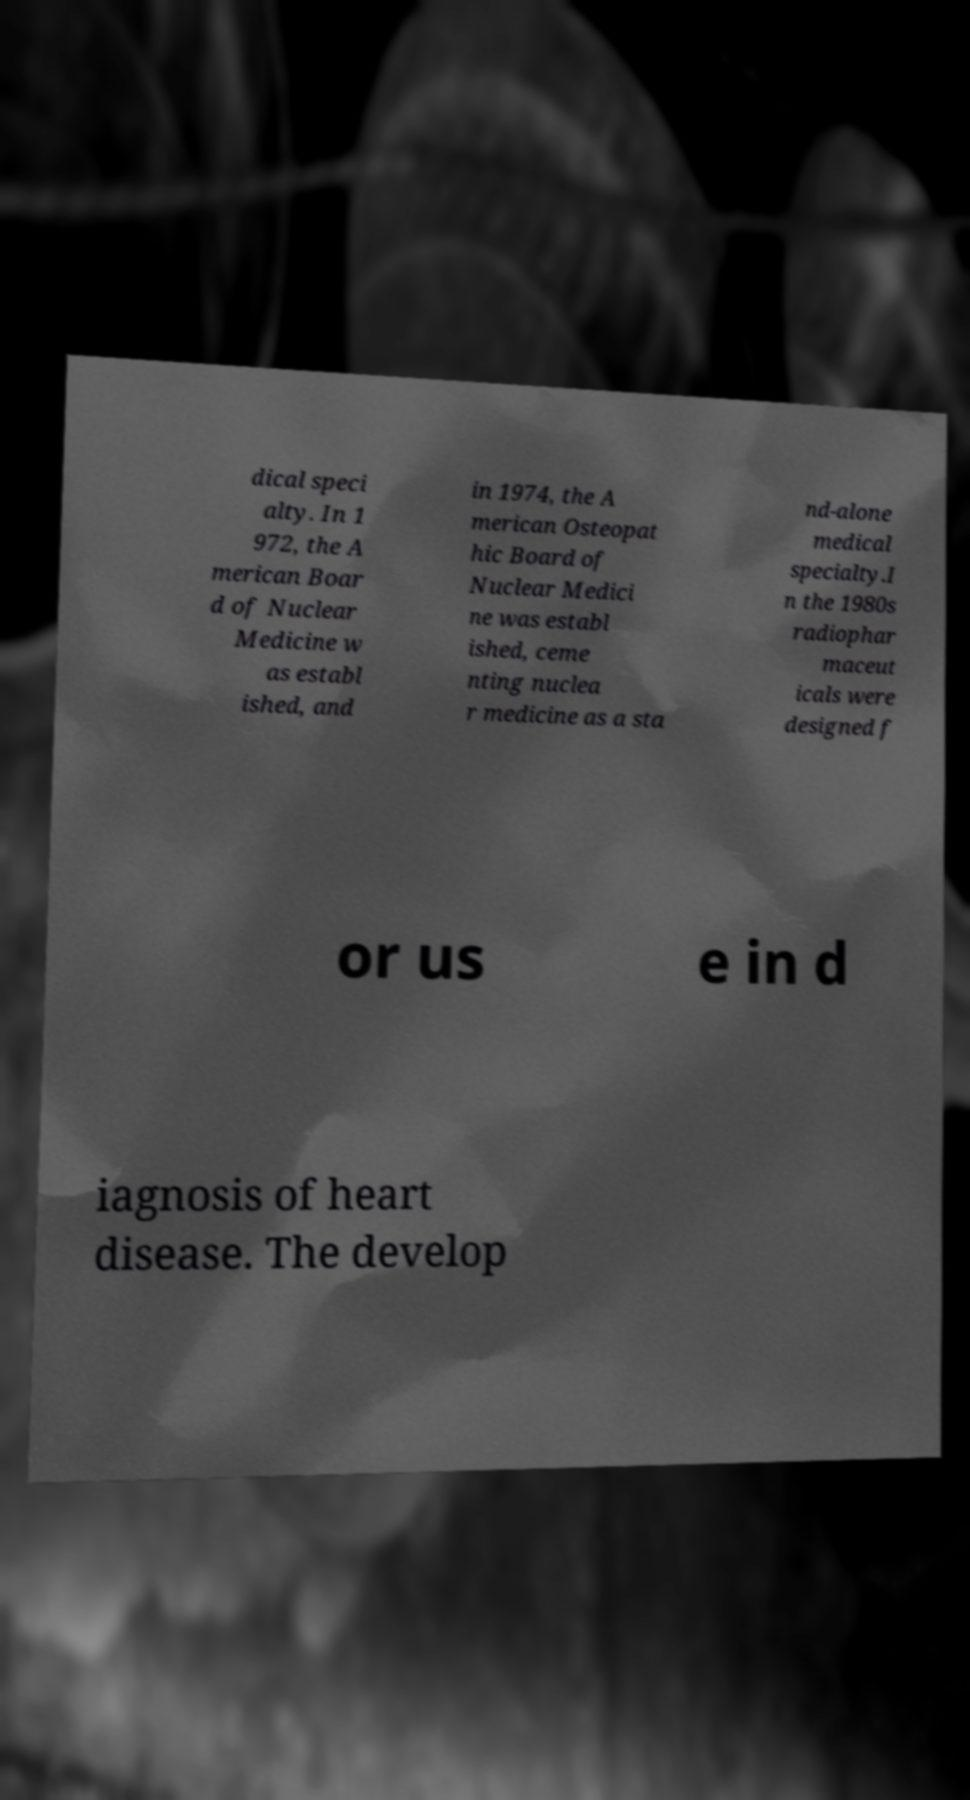I need the written content from this picture converted into text. Can you do that? dical speci alty. In 1 972, the A merican Boar d of Nuclear Medicine w as establ ished, and in 1974, the A merican Osteopat hic Board of Nuclear Medici ne was establ ished, ceme nting nuclea r medicine as a sta nd-alone medical specialty.I n the 1980s radiophar maceut icals were designed f or us e in d iagnosis of heart disease. The develop 